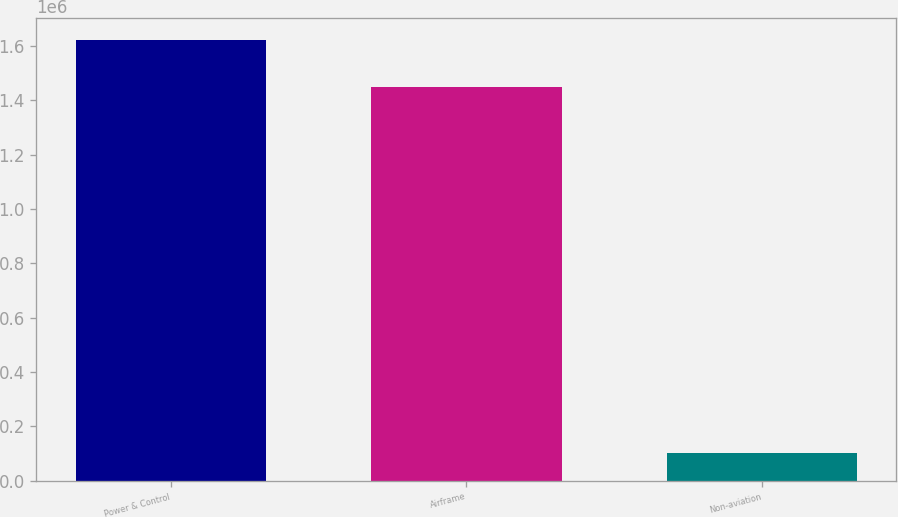Convert chart. <chart><loc_0><loc_0><loc_500><loc_500><bar_chart><fcel>Power & Control<fcel>Airframe<fcel>Non-aviation<nl><fcel>1.62174e+06<fcel>1.44789e+06<fcel>101776<nl></chart> 